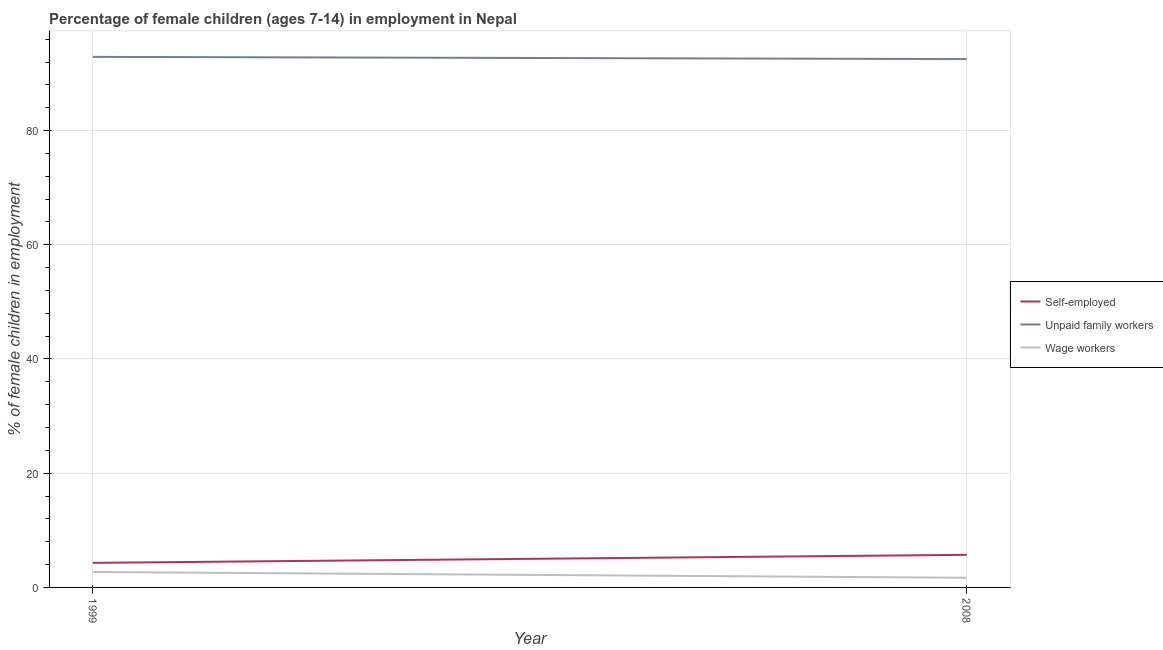Does the line corresponding to percentage of children employed as unpaid family workers intersect with the line corresponding to percentage of self employed children?
Provide a short and direct response. No. Is the number of lines equal to the number of legend labels?
Give a very brief answer. Yes. What is the percentage of self employed children in 2008?
Your response must be concise. 5.71. Across all years, what is the maximum percentage of self employed children?
Your answer should be compact. 5.71. Across all years, what is the minimum percentage of children employed as wage workers?
Give a very brief answer. 1.69. In which year was the percentage of children employed as wage workers maximum?
Ensure brevity in your answer.  1999. What is the total percentage of self employed children in the graph?
Offer a terse response. 10.01. What is the difference between the percentage of children employed as unpaid family workers in 1999 and that in 2008?
Your response must be concise. 0.39. What is the difference between the percentage of children employed as unpaid family workers in 2008 and the percentage of children employed as wage workers in 1999?
Your answer should be very brief. 89.81. What is the average percentage of children employed as wage workers per year?
Provide a short and direct response. 2.2. In the year 1999, what is the difference between the percentage of self employed children and percentage of children employed as wage workers?
Give a very brief answer. 1.6. What is the ratio of the percentage of self employed children in 1999 to that in 2008?
Make the answer very short. 0.75. Does the percentage of children employed as unpaid family workers monotonically increase over the years?
Offer a terse response. No. Is the percentage of children employed as unpaid family workers strictly greater than the percentage of self employed children over the years?
Give a very brief answer. Yes. Is the percentage of self employed children strictly less than the percentage of children employed as wage workers over the years?
Your answer should be very brief. No. How many years are there in the graph?
Keep it short and to the point. 2. What is the difference between two consecutive major ticks on the Y-axis?
Offer a very short reply. 20. Are the values on the major ticks of Y-axis written in scientific E-notation?
Offer a terse response. No. How many legend labels are there?
Ensure brevity in your answer.  3. What is the title of the graph?
Provide a succinct answer. Percentage of female children (ages 7-14) in employment in Nepal. What is the label or title of the X-axis?
Provide a short and direct response. Year. What is the label or title of the Y-axis?
Offer a terse response. % of female children in employment. What is the % of female children in employment of Unpaid family workers in 1999?
Provide a succinct answer. 92.9. What is the % of female children in employment of Self-employed in 2008?
Provide a short and direct response. 5.71. What is the % of female children in employment of Unpaid family workers in 2008?
Keep it short and to the point. 92.51. What is the % of female children in employment of Wage workers in 2008?
Give a very brief answer. 1.69. Across all years, what is the maximum % of female children in employment of Self-employed?
Keep it short and to the point. 5.71. Across all years, what is the maximum % of female children in employment in Unpaid family workers?
Give a very brief answer. 92.9. Across all years, what is the minimum % of female children in employment in Self-employed?
Ensure brevity in your answer.  4.3. Across all years, what is the minimum % of female children in employment in Unpaid family workers?
Ensure brevity in your answer.  92.51. Across all years, what is the minimum % of female children in employment of Wage workers?
Ensure brevity in your answer.  1.69. What is the total % of female children in employment in Self-employed in the graph?
Your answer should be very brief. 10.01. What is the total % of female children in employment of Unpaid family workers in the graph?
Your answer should be compact. 185.41. What is the total % of female children in employment in Wage workers in the graph?
Your answer should be compact. 4.39. What is the difference between the % of female children in employment of Self-employed in 1999 and that in 2008?
Provide a short and direct response. -1.41. What is the difference between the % of female children in employment of Unpaid family workers in 1999 and that in 2008?
Keep it short and to the point. 0.39. What is the difference between the % of female children in employment in Wage workers in 1999 and that in 2008?
Provide a short and direct response. 1.01. What is the difference between the % of female children in employment in Self-employed in 1999 and the % of female children in employment in Unpaid family workers in 2008?
Your answer should be compact. -88.21. What is the difference between the % of female children in employment in Self-employed in 1999 and the % of female children in employment in Wage workers in 2008?
Make the answer very short. 2.61. What is the difference between the % of female children in employment in Unpaid family workers in 1999 and the % of female children in employment in Wage workers in 2008?
Provide a succinct answer. 91.21. What is the average % of female children in employment in Self-employed per year?
Your answer should be compact. 5. What is the average % of female children in employment of Unpaid family workers per year?
Offer a terse response. 92.7. What is the average % of female children in employment of Wage workers per year?
Provide a succinct answer. 2.19. In the year 1999, what is the difference between the % of female children in employment of Self-employed and % of female children in employment of Unpaid family workers?
Offer a very short reply. -88.6. In the year 1999, what is the difference between the % of female children in employment in Unpaid family workers and % of female children in employment in Wage workers?
Provide a succinct answer. 90.2. In the year 2008, what is the difference between the % of female children in employment in Self-employed and % of female children in employment in Unpaid family workers?
Provide a short and direct response. -86.8. In the year 2008, what is the difference between the % of female children in employment of Self-employed and % of female children in employment of Wage workers?
Give a very brief answer. 4.02. In the year 2008, what is the difference between the % of female children in employment in Unpaid family workers and % of female children in employment in Wage workers?
Offer a very short reply. 90.82. What is the ratio of the % of female children in employment in Self-employed in 1999 to that in 2008?
Keep it short and to the point. 0.75. What is the ratio of the % of female children in employment in Wage workers in 1999 to that in 2008?
Keep it short and to the point. 1.6. What is the difference between the highest and the second highest % of female children in employment in Self-employed?
Offer a terse response. 1.41. What is the difference between the highest and the second highest % of female children in employment of Unpaid family workers?
Ensure brevity in your answer.  0.39. What is the difference between the highest and the lowest % of female children in employment of Self-employed?
Keep it short and to the point. 1.41. What is the difference between the highest and the lowest % of female children in employment of Unpaid family workers?
Your answer should be very brief. 0.39. What is the difference between the highest and the lowest % of female children in employment of Wage workers?
Give a very brief answer. 1.01. 